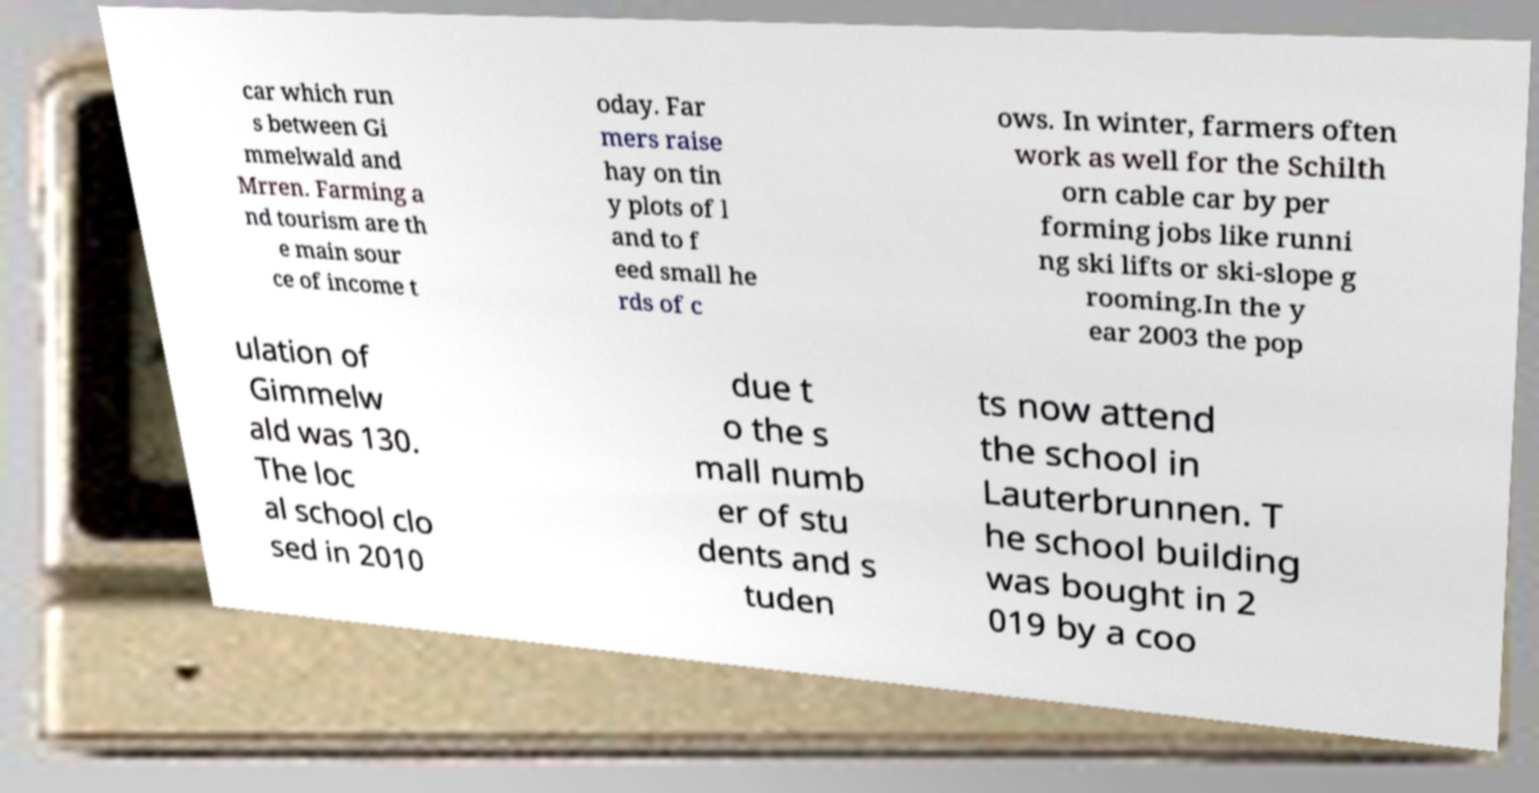Could you assist in decoding the text presented in this image and type it out clearly? car which run s between Gi mmelwald and Mrren. Farming a nd tourism are th e main sour ce of income t oday. Far mers raise hay on tin y plots of l and to f eed small he rds of c ows. In winter, farmers often work as well for the Schilth orn cable car by per forming jobs like runni ng ski lifts or ski-slope g rooming.In the y ear 2003 the pop ulation of Gimmelw ald was 130. The loc al school clo sed in 2010 due t o the s mall numb er of stu dents and s tuden ts now attend the school in Lauterbrunnen. T he school building was bought in 2 019 by a coo 